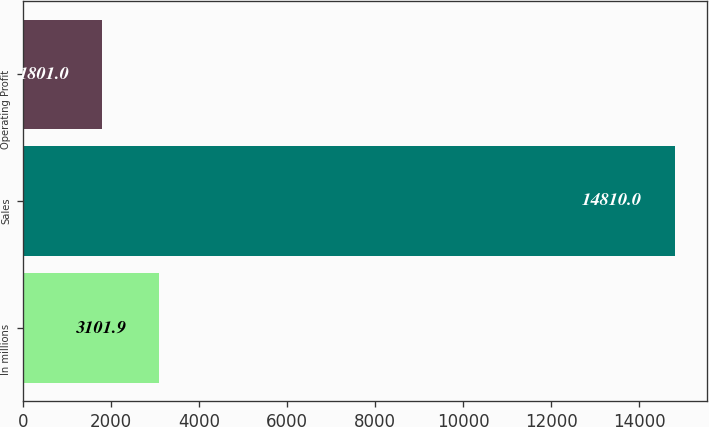<chart> <loc_0><loc_0><loc_500><loc_500><bar_chart><fcel>In millions<fcel>Sales<fcel>Operating Profit<nl><fcel>3101.9<fcel>14810<fcel>1801<nl></chart> 